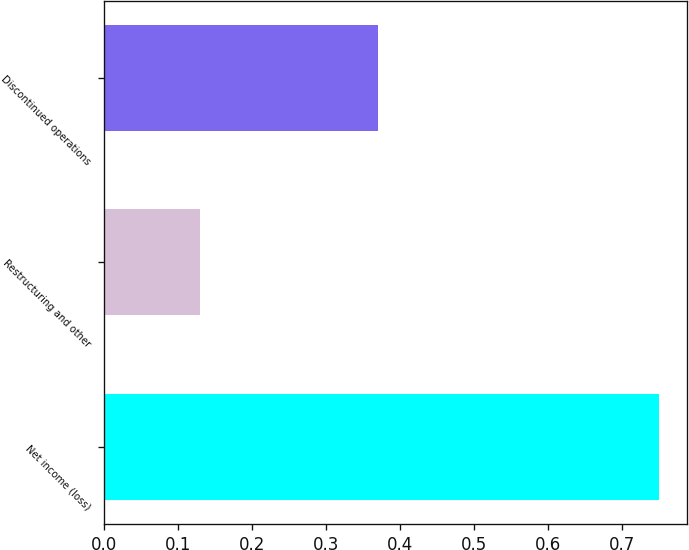Convert chart. <chart><loc_0><loc_0><loc_500><loc_500><bar_chart><fcel>Net income (loss)<fcel>Restructuring and other<fcel>Discontinued operations<nl><fcel>0.75<fcel>0.13<fcel>0.37<nl></chart> 